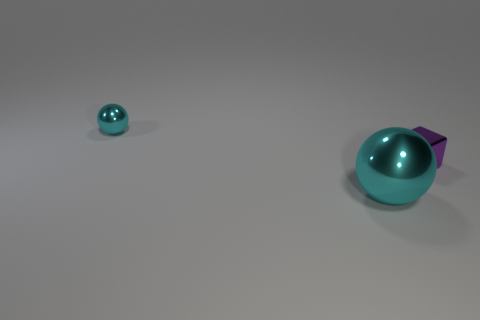Is the number of tiny purple metallic blocks that are on the left side of the big sphere less than the number of tiny blocks?
Keep it short and to the point. Yes. What number of blue objects are there?
Your answer should be very brief. 0. There is a tiny thing that is on the left side of the cyan sphere that is right of the tiny cyan ball; what is its shape?
Your answer should be compact. Sphere. What number of large metal balls are left of the purple metal cube?
Keep it short and to the point. 1. Is the tiny cyan ball made of the same material as the cyan object to the right of the small cyan sphere?
Offer a very short reply. Yes. Is there a cyan metallic ball of the same size as the metal cube?
Give a very brief answer. Yes. Is the number of small cyan things on the right side of the small cyan object the same as the number of metal things?
Provide a short and direct response. No. The purple metallic object is what size?
Provide a short and direct response. Small. What number of things are behind the cyan object that is in front of the tiny cyan thing?
Your response must be concise. 2. There is a metal object that is to the left of the purple block and behind the large metallic sphere; what shape is it?
Keep it short and to the point. Sphere. 